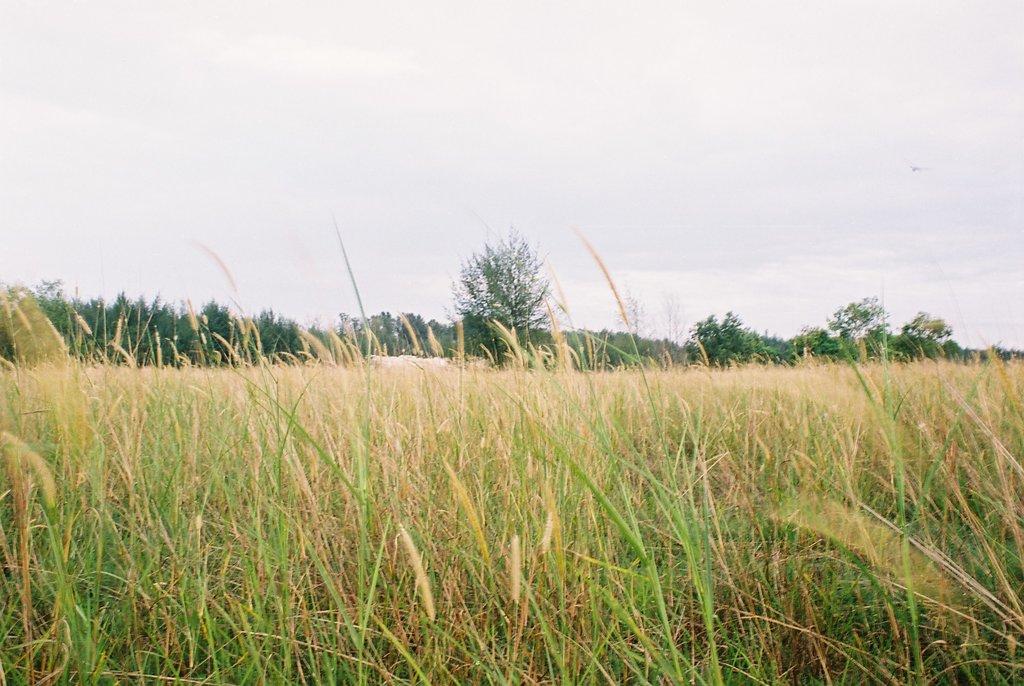In one or two sentences, can you explain what this image depicts? In the foreground of this image, there is a grass and in the middle of the picture, we see few trees. On top, there is the sky. 